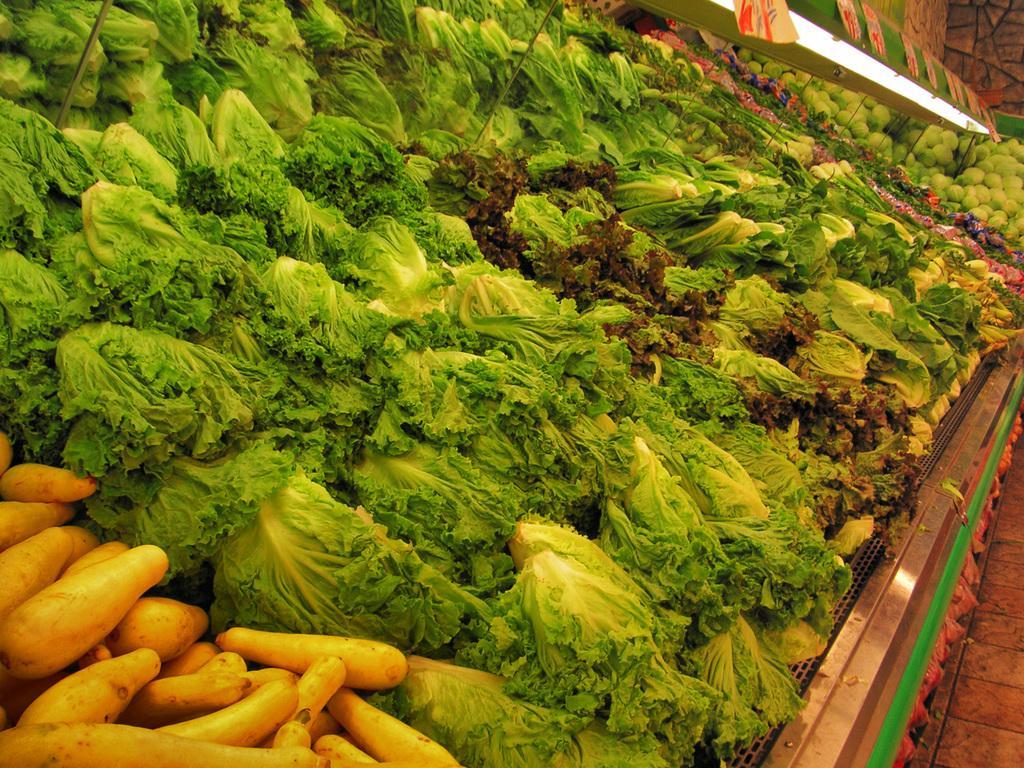Describe this image in one or two sentences. In this image I can see many vegetables. There is a light at the top. 